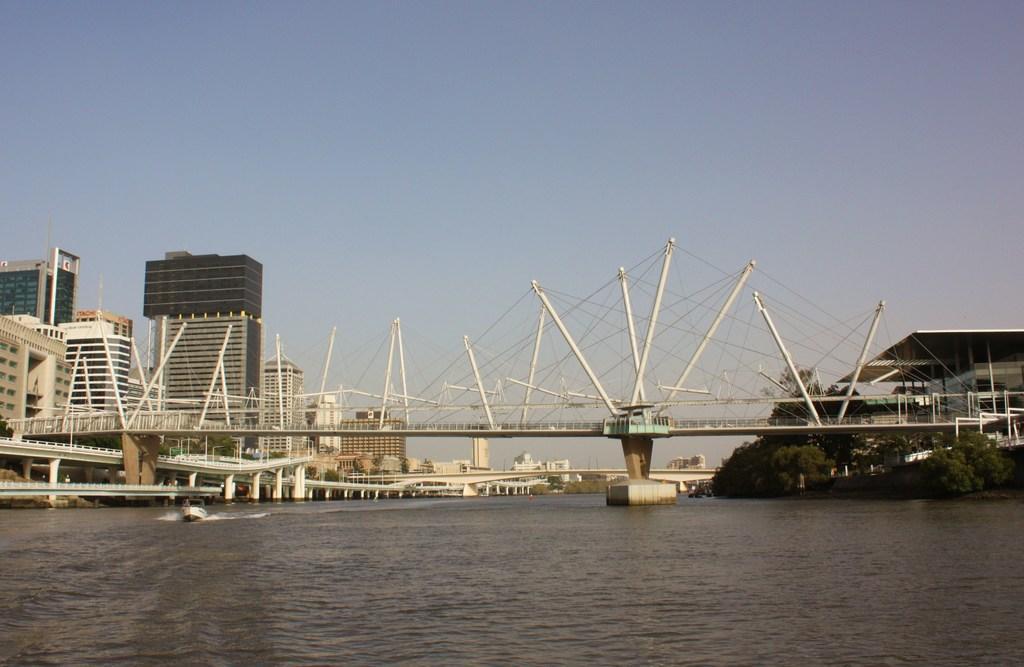Could you give a brief overview of what you see in this image? In this image we can see bridges. At the bottom there is water and we can see a boat on the water. In the background there are buildings, trees and sky. 